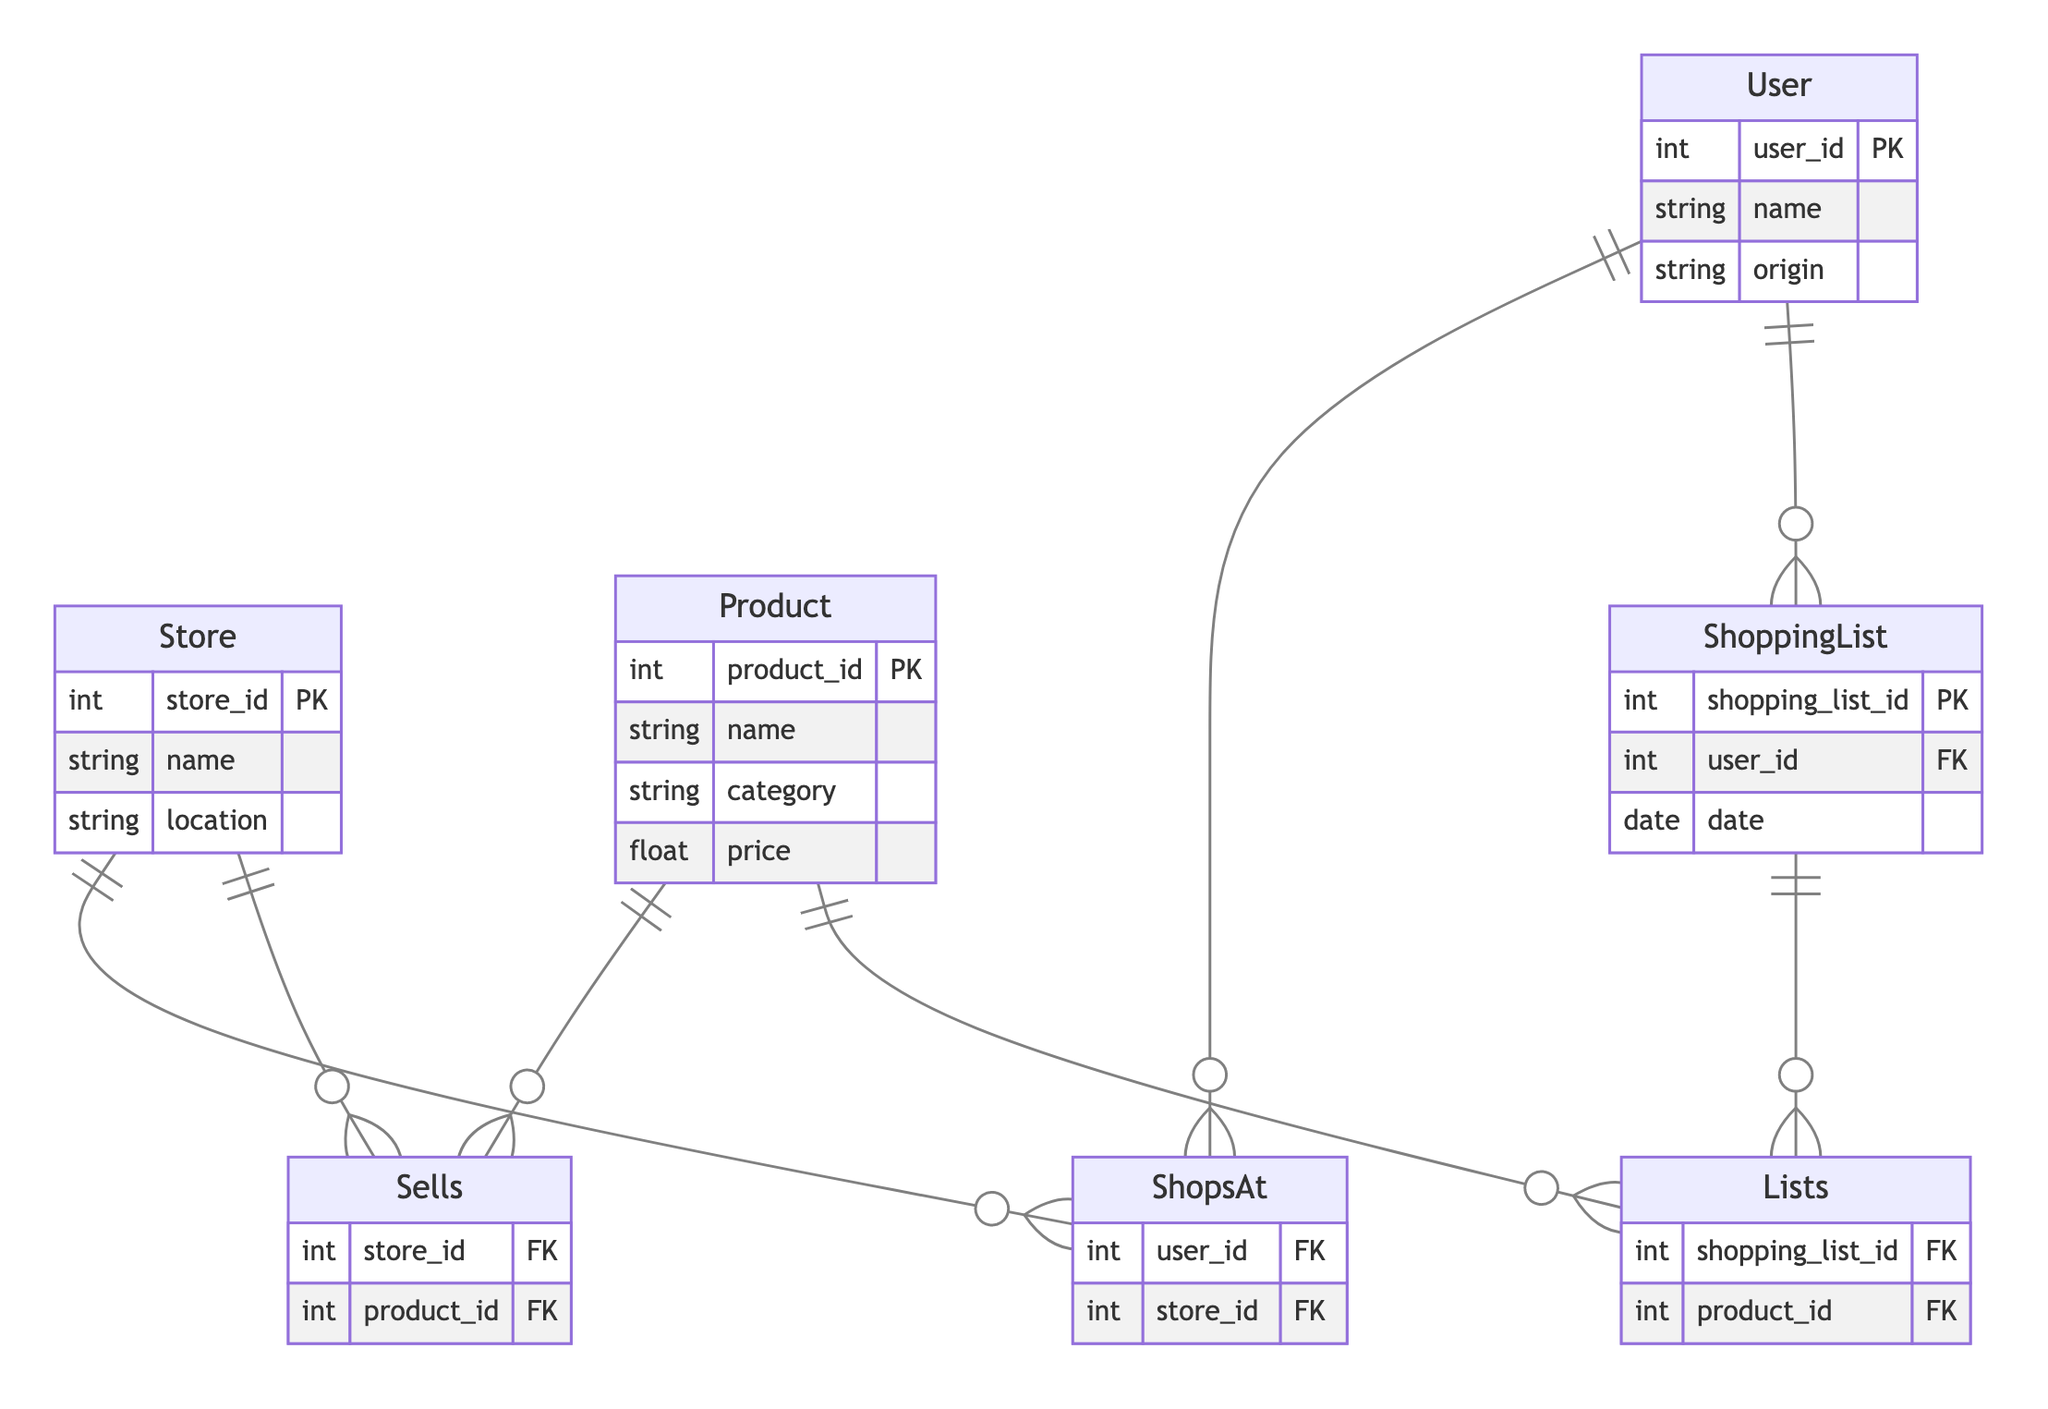What is the primary key of the User entity? The primary key of the User entity is user_id, which uniquely identifies each user in the database.
Answer: user_id How many entities are represented in the diagram? The diagram contains four entities: Store, Product, ShoppingList, and User.
Answer: four What type of relationship exists between the Store and Product entities? The Store and Product entities have a many-to-many relationship labeled as "Sells," indicating that a store can sell multiple products and a product can be sold by multiple stores.
Answer: many-to-many Which entity has a one-to-many relationship with ShoppingList? The User entity has a one-to-many relationship with ShoppingList, meaning that a user can have multiple shopping lists associated with them.
Answer: User How many attributes does the Product entity have? The Product entity has four attributes: product_id, name, category, and price.
Answer: four What is the name of the relationship that connects ShoppingList to Product? The relationship connecting ShoppingList to Product is named "Lists." This indicates that each shopping list can contain multiple products.
Answer: Lists Which entity contains the attribute 'location'? The attribute 'location' is found in the Store entity, which provides the geographical location of each store.
Answer: Store How many relationships are depicted in the diagram? There are three relationships shown in the diagram: Lists, ShopsAt, and Sells, connecting different entities accordingly.
Answer: three What is the data type of the price attribute in Product? The data type of the price attribute in Product is float, which represents currency values.
Answer: float 